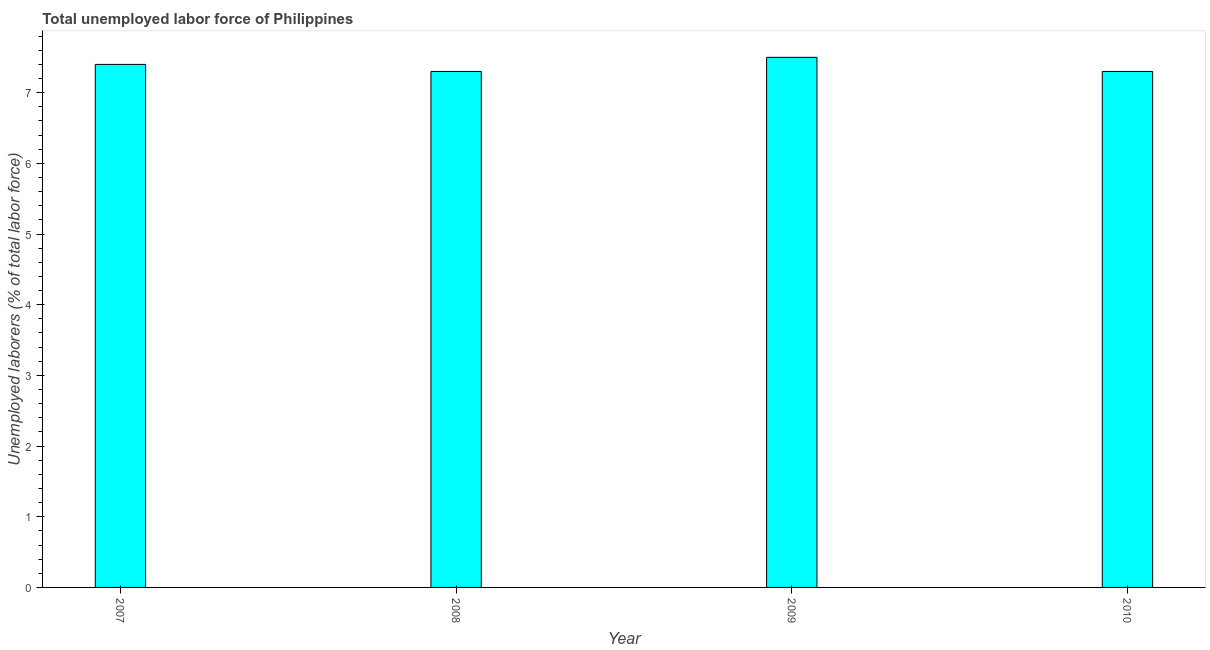Does the graph contain any zero values?
Offer a terse response. No. Does the graph contain grids?
Offer a terse response. No. What is the title of the graph?
Provide a succinct answer. Total unemployed labor force of Philippines. What is the label or title of the Y-axis?
Keep it short and to the point. Unemployed laborers (% of total labor force). What is the total unemployed labour force in 2008?
Your response must be concise. 7.3. Across all years, what is the maximum total unemployed labour force?
Provide a succinct answer. 7.5. Across all years, what is the minimum total unemployed labour force?
Provide a short and direct response. 7.3. In which year was the total unemployed labour force minimum?
Provide a succinct answer. 2008. What is the sum of the total unemployed labour force?
Offer a very short reply. 29.5. What is the difference between the total unemployed labour force in 2007 and 2009?
Your response must be concise. -0.1. What is the average total unemployed labour force per year?
Keep it short and to the point. 7.38. What is the median total unemployed labour force?
Offer a terse response. 7.35. In how many years, is the total unemployed labour force greater than 6 %?
Your response must be concise. 4. What is the ratio of the total unemployed labour force in 2007 to that in 2008?
Keep it short and to the point. 1.01. Is the difference between the total unemployed labour force in 2008 and 2010 greater than the difference between any two years?
Your response must be concise. No. What is the difference between the highest and the second highest total unemployed labour force?
Provide a succinct answer. 0.1. What is the difference between the highest and the lowest total unemployed labour force?
Keep it short and to the point. 0.2. In how many years, is the total unemployed labour force greater than the average total unemployed labour force taken over all years?
Provide a succinct answer. 2. What is the difference between two consecutive major ticks on the Y-axis?
Make the answer very short. 1. What is the Unemployed laborers (% of total labor force) in 2007?
Your response must be concise. 7.4. What is the Unemployed laborers (% of total labor force) in 2008?
Give a very brief answer. 7.3. What is the Unemployed laborers (% of total labor force) in 2010?
Keep it short and to the point. 7.3. What is the difference between the Unemployed laborers (% of total labor force) in 2008 and 2010?
Make the answer very short. 0. What is the ratio of the Unemployed laborers (% of total labor force) in 2007 to that in 2009?
Offer a terse response. 0.99. What is the ratio of the Unemployed laborers (% of total labor force) in 2007 to that in 2010?
Ensure brevity in your answer.  1.01. What is the ratio of the Unemployed laborers (% of total labor force) in 2008 to that in 2009?
Offer a terse response. 0.97. What is the ratio of the Unemployed laborers (% of total labor force) in 2009 to that in 2010?
Your response must be concise. 1.03. 